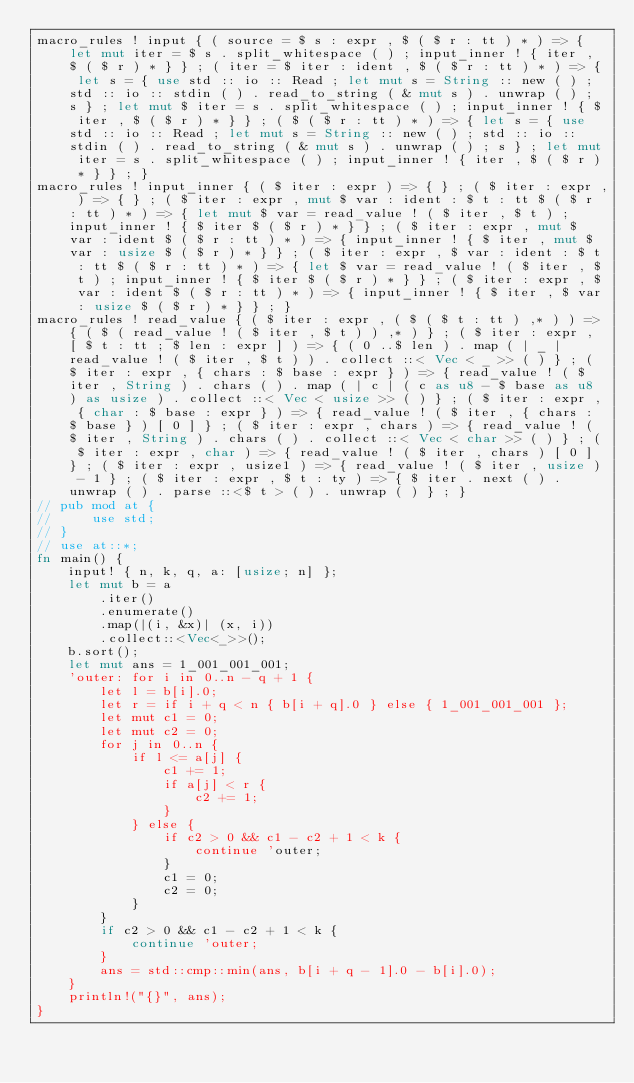Convert code to text. <code><loc_0><loc_0><loc_500><loc_500><_Rust_>macro_rules ! input { ( source = $ s : expr , $ ( $ r : tt ) * ) => { let mut iter = $ s . split_whitespace ( ) ; input_inner ! { iter , $ ( $ r ) * } } ; ( iter = $ iter : ident , $ ( $ r : tt ) * ) => { let s = { use std :: io :: Read ; let mut s = String :: new ( ) ; std :: io :: stdin ( ) . read_to_string ( & mut s ) . unwrap ( ) ; s } ; let mut $ iter = s . split_whitespace ( ) ; input_inner ! { $ iter , $ ( $ r ) * } } ; ( $ ( $ r : tt ) * ) => { let s = { use std :: io :: Read ; let mut s = String :: new ( ) ; std :: io :: stdin ( ) . read_to_string ( & mut s ) . unwrap ( ) ; s } ; let mut iter = s . split_whitespace ( ) ; input_inner ! { iter , $ ( $ r ) * } } ; }
macro_rules ! input_inner { ( $ iter : expr ) => { } ; ( $ iter : expr , ) => { } ; ( $ iter : expr , mut $ var : ident : $ t : tt $ ( $ r : tt ) * ) => { let mut $ var = read_value ! ( $ iter , $ t ) ; input_inner ! { $ iter $ ( $ r ) * } } ; ( $ iter : expr , mut $ var : ident $ ( $ r : tt ) * ) => { input_inner ! { $ iter , mut $ var : usize $ ( $ r ) * } } ; ( $ iter : expr , $ var : ident : $ t : tt $ ( $ r : tt ) * ) => { let $ var = read_value ! ( $ iter , $ t ) ; input_inner ! { $ iter $ ( $ r ) * } } ; ( $ iter : expr , $ var : ident $ ( $ r : tt ) * ) => { input_inner ! { $ iter , $ var : usize $ ( $ r ) * } } ; }
macro_rules ! read_value { ( $ iter : expr , ( $ ( $ t : tt ) ,* ) ) => { ( $ ( read_value ! ( $ iter , $ t ) ) ,* ) } ; ( $ iter : expr , [ $ t : tt ; $ len : expr ] ) => { ( 0 ..$ len ) . map ( | _ | read_value ! ( $ iter , $ t ) ) . collect ::< Vec < _ >> ( ) } ; ( $ iter : expr , { chars : $ base : expr } ) => { read_value ! ( $ iter , String ) . chars ( ) . map ( | c | ( c as u8 - $ base as u8 ) as usize ) . collect ::< Vec < usize >> ( ) } ; ( $ iter : expr , { char : $ base : expr } ) => { read_value ! ( $ iter , { chars : $ base } ) [ 0 ] } ; ( $ iter : expr , chars ) => { read_value ! ( $ iter , String ) . chars ( ) . collect ::< Vec < char >> ( ) } ; ( $ iter : expr , char ) => { read_value ! ( $ iter , chars ) [ 0 ] } ; ( $ iter : expr , usize1 ) => { read_value ! ( $ iter , usize ) - 1 } ; ( $ iter : expr , $ t : ty ) => { $ iter . next ( ) . unwrap ( ) . parse ::<$ t > ( ) . unwrap ( ) } ; }
// pub mod at {
//     use std;
// }
// use at::*;
fn main() {
    input! { n, k, q, a: [usize; n] };
    let mut b = a
        .iter()
        .enumerate()
        .map(|(i, &x)| (x, i))
        .collect::<Vec<_>>();
    b.sort();
    let mut ans = 1_001_001_001;
    'outer: for i in 0..n - q + 1 {
        let l = b[i].0;
        let r = if i + q < n { b[i + q].0 } else { 1_001_001_001 };
        let mut c1 = 0;
        let mut c2 = 0;
        for j in 0..n {
            if l <= a[j] {
                c1 += 1;
                if a[j] < r {
                    c2 += 1;
                }
            } else {
                if c2 > 0 && c1 - c2 + 1 < k {
                    continue 'outer;
                }
                c1 = 0;
                c2 = 0;
            }
        }
        if c2 > 0 && c1 - c2 + 1 < k {
            continue 'outer;
        }
        ans = std::cmp::min(ans, b[i + q - 1].0 - b[i].0);
    }
    println!("{}", ans);
}
</code> 